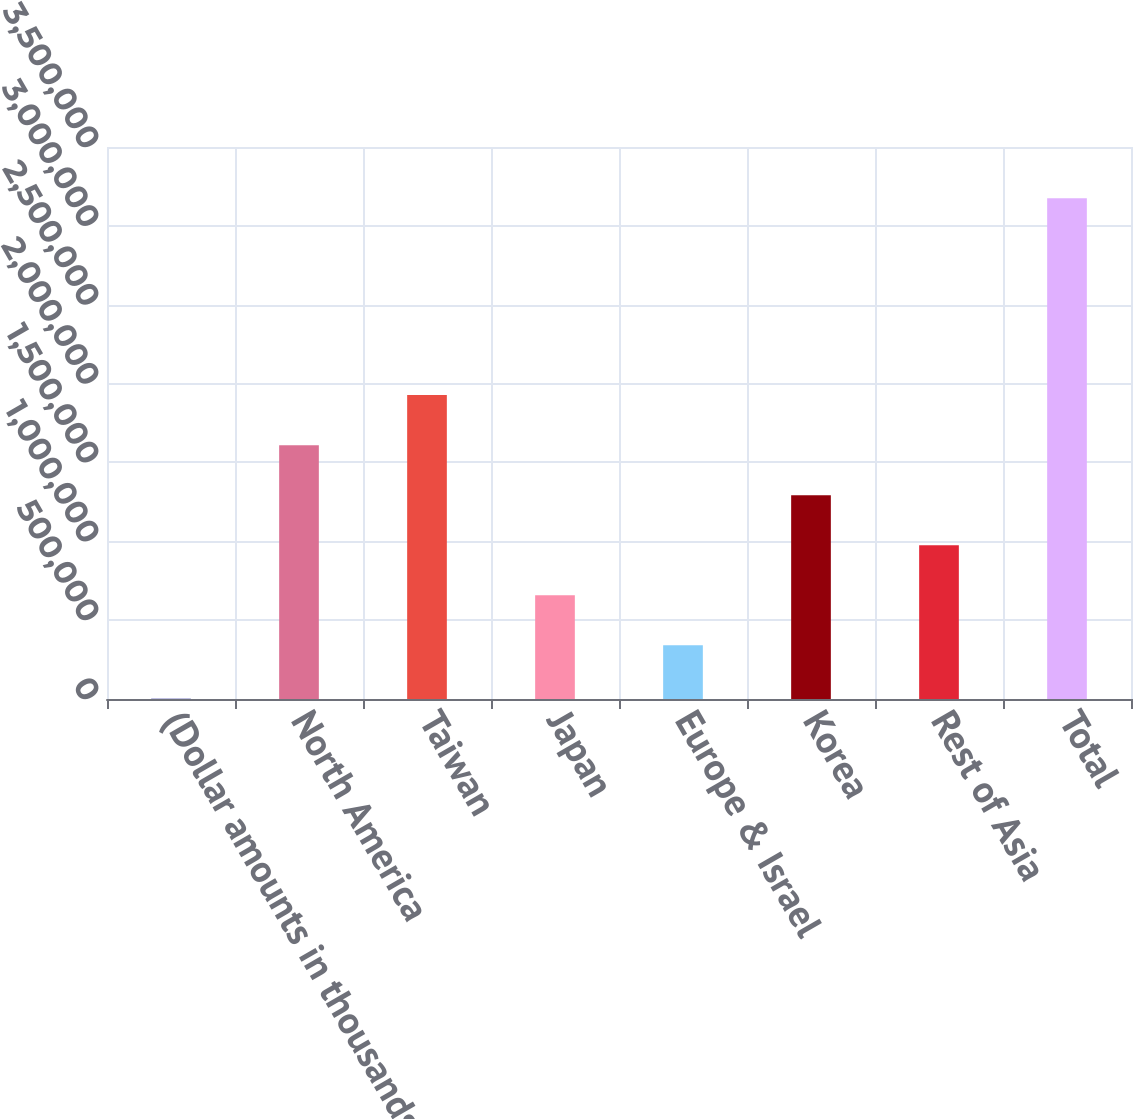Convert chart to OTSL. <chart><loc_0><loc_0><loc_500><loc_500><bar_chart><fcel>(Dollar amounts in thousands)<fcel>North America<fcel>Taiwan<fcel>Japan<fcel>Europe & Israel<fcel>Korea<fcel>Rest of Asia<fcel>Total<nl><fcel>2011<fcel>1.60951e+06<fcel>1.92683e+06<fcel>657565<fcel>340249<fcel>1.2922e+06<fcel>974880<fcel>3.17517e+06<nl></chart> 